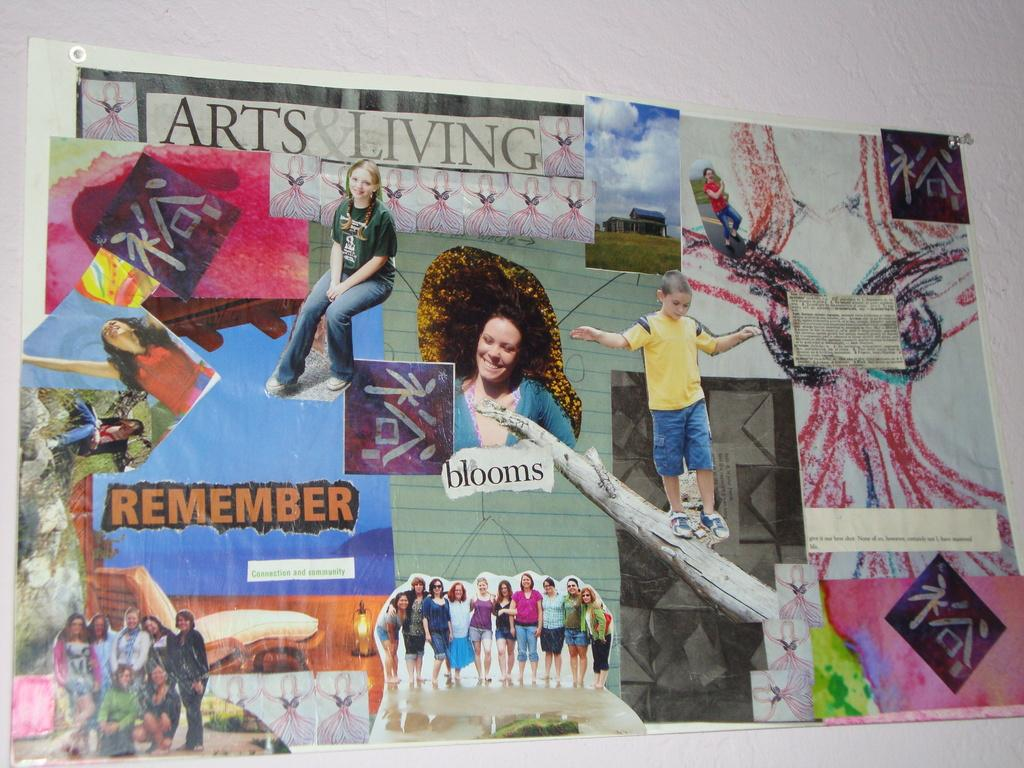What is present in the image that has both pictures and text? There is a paper in the image that has both pictures and text. Can you describe the content of the paper? The paper has pictures and text on it. What type of stew is being cooked in the image? There is no stew present in the image; it only features a paper with pictures and text. 